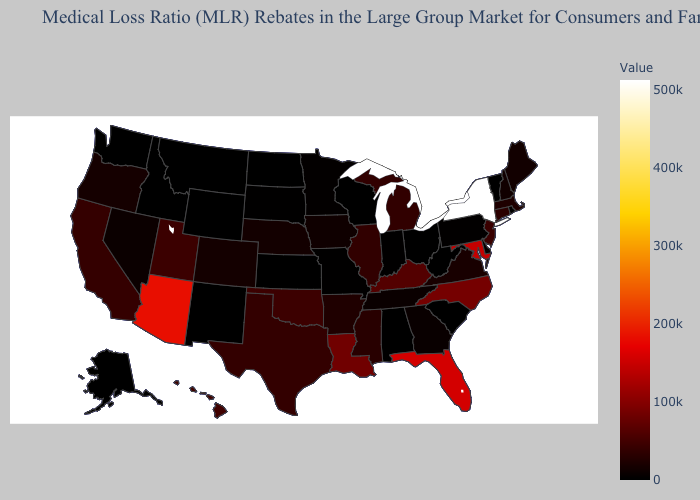Does Connecticut have the highest value in the Northeast?
Concise answer only. No. Which states have the lowest value in the Northeast?
Write a very short answer. Vermont. Does Vermont have the lowest value in the USA?
Short answer required. Yes. Among the states that border Arizona , does Nevada have the lowest value?
Be succinct. No. Does North Carolina have a higher value than Tennessee?
Short answer required. Yes. Does South Carolina have the lowest value in the South?
Give a very brief answer. Yes. 